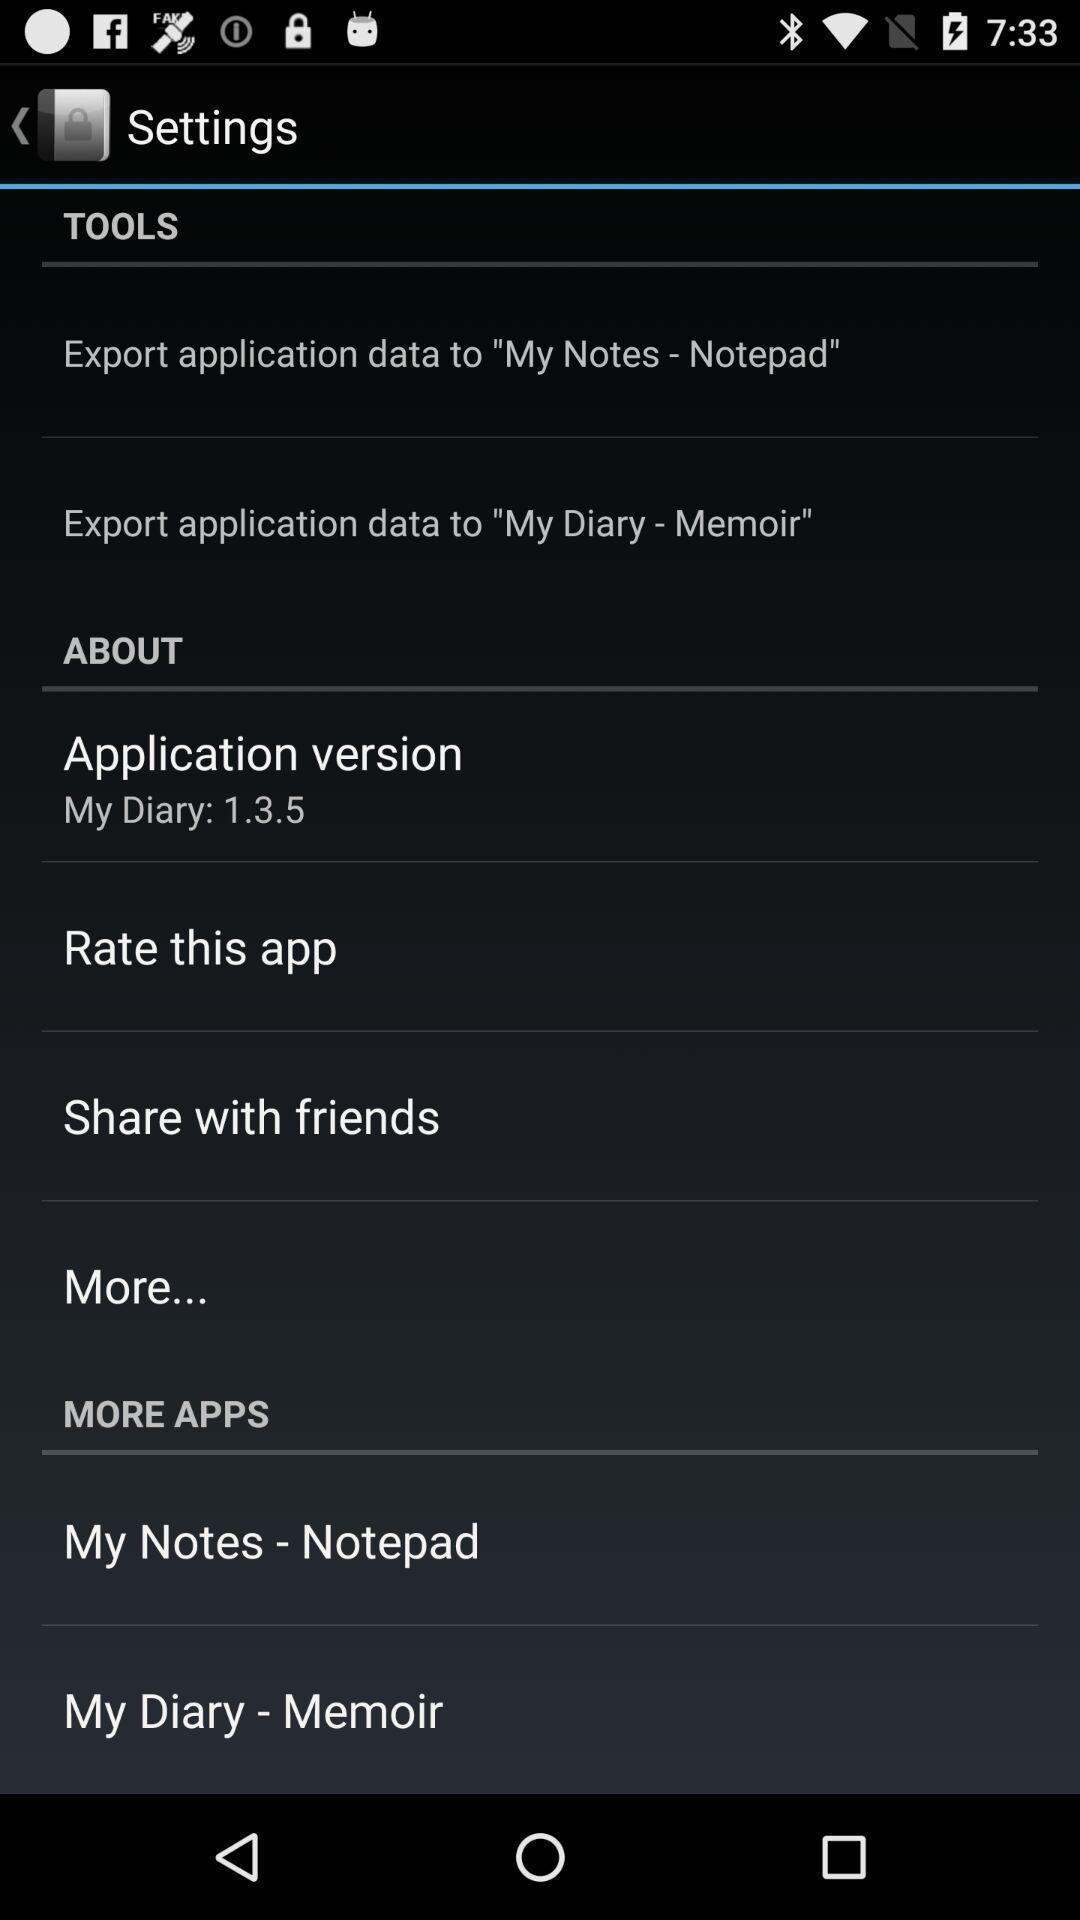Explain the elements present in this screenshot. Settings page with various options. 